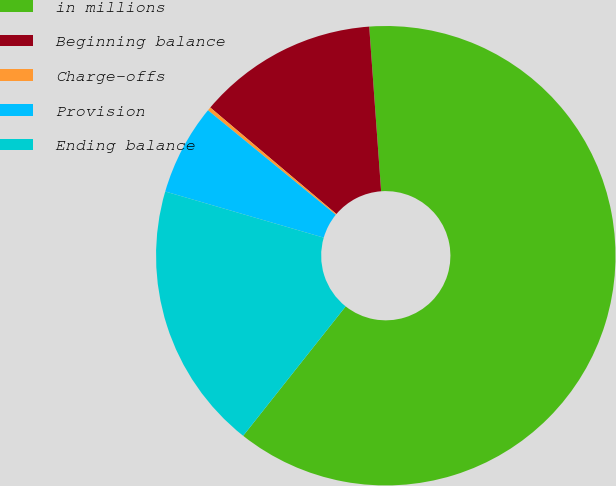Convert chart. <chart><loc_0><loc_0><loc_500><loc_500><pie_chart><fcel>in millions<fcel>Beginning balance<fcel>Charge-offs<fcel>Provision<fcel>Ending balance<nl><fcel>61.81%<fcel>12.69%<fcel>0.25%<fcel>6.4%<fcel>18.85%<nl></chart> 